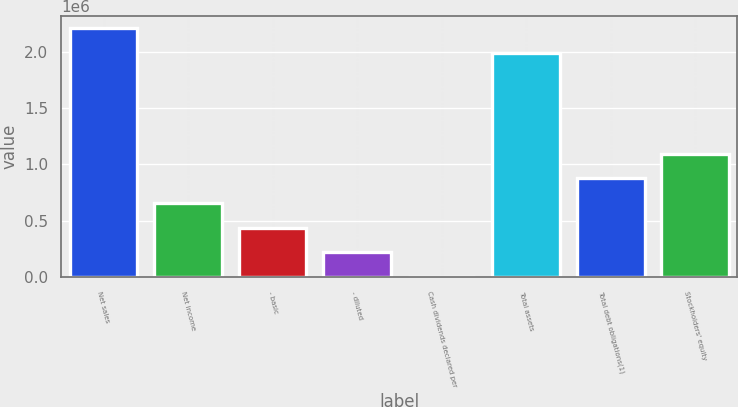<chart> <loc_0><loc_0><loc_500><loc_500><bar_chart><fcel>Net sales<fcel>Net income<fcel>- basic<fcel>- diluted<fcel>Cash dividends declared per<fcel>Total assets<fcel>Total debt obligations(1)<fcel>Stockholders' equity<nl><fcel>2.20568e+06<fcel>656114<fcel>437410<fcel>218706<fcel>1<fcel>1.98698e+06<fcel>874819<fcel>1.09352e+06<nl></chart> 